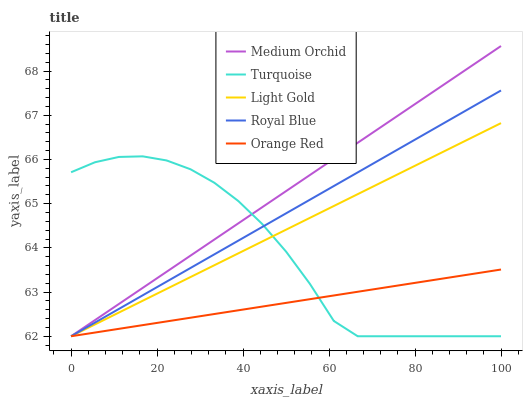Does Turquoise have the minimum area under the curve?
Answer yes or no. No. Does Turquoise have the maximum area under the curve?
Answer yes or no. No. Is Medium Orchid the smoothest?
Answer yes or no. No. Is Medium Orchid the roughest?
Answer yes or no. No. Does Turquoise have the highest value?
Answer yes or no. No. 